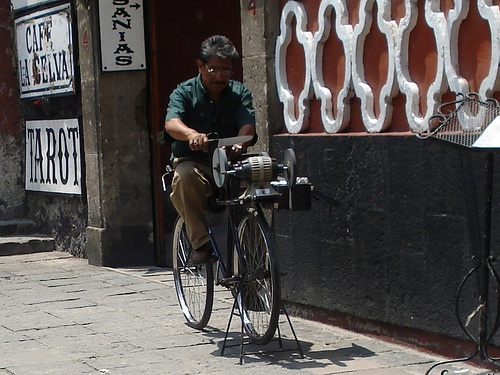Describe the objects in this image and their specific colors. I can see bicycle in black, gray, darkgray, and lightgray tones, people in black, gray, and maroon tones, and knife in black and gray tones in this image. 